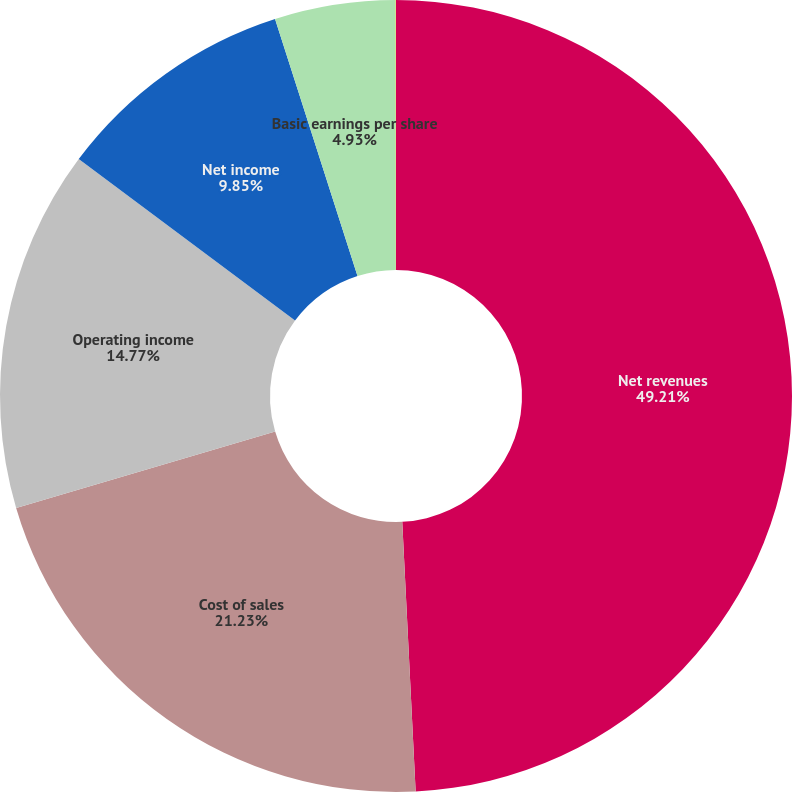Convert chart to OTSL. <chart><loc_0><loc_0><loc_500><loc_500><pie_chart><fcel>Net revenues<fcel>Cost of sales<fcel>Operating income<fcel>Net income<fcel>Basic earnings per share<fcel>Diluted earnings per share<nl><fcel>49.21%<fcel>21.23%<fcel>14.77%<fcel>9.85%<fcel>4.93%<fcel>0.01%<nl></chart> 